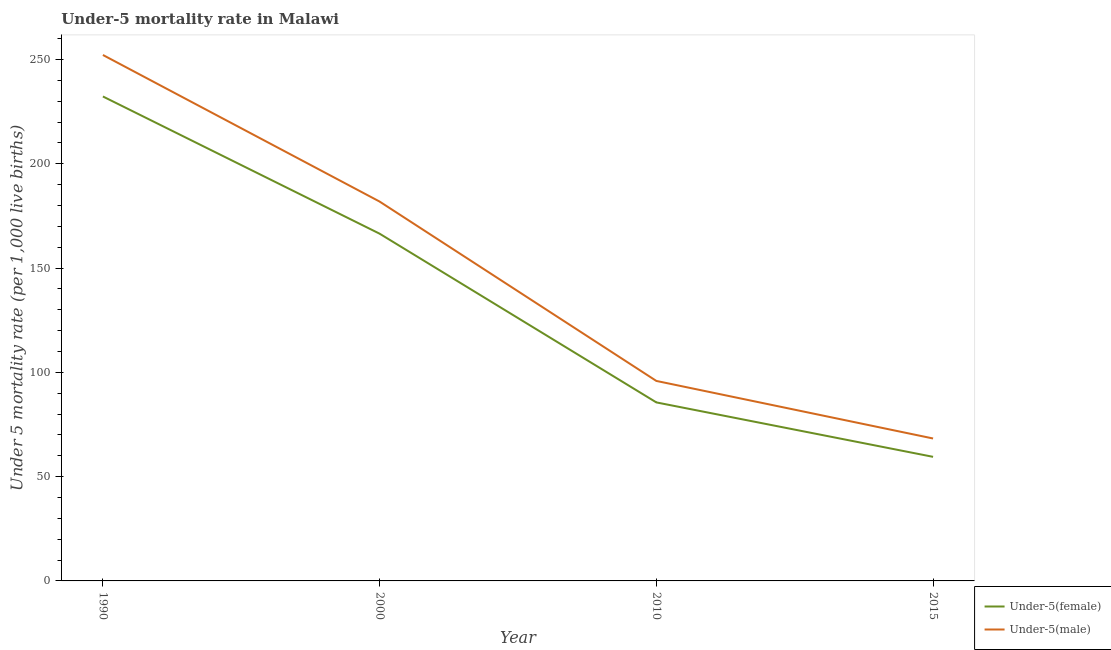Is the number of lines equal to the number of legend labels?
Provide a succinct answer. Yes. What is the under-5 female mortality rate in 2000?
Give a very brief answer. 166.5. Across all years, what is the maximum under-5 male mortality rate?
Make the answer very short. 252.2. Across all years, what is the minimum under-5 male mortality rate?
Your answer should be compact. 68.3. In which year was the under-5 female mortality rate minimum?
Ensure brevity in your answer.  2015. What is the total under-5 female mortality rate in the graph?
Give a very brief answer. 543.9. What is the difference between the under-5 female mortality rate in 1990 and that in 2000?
Offer a terse response. 65.8. What is the difference between the under-5 female mortality rate in 2000 and the under-5 male mortality rate in 2010?
Your answer should be compact. 70.6. What is the average under-5 male mortality rate per year?
Your answer should be very brief. 149.57. In the year 2015, what is the difference between the under-5 female mortality rate and under-5 male mortality rate?
Offer a very short reply. -8.8. What is the ratio of the under-5 female mortality rate in 1990 to that in 2000?
Offer a terse response. 1.4. Is the under-5 female mortality rate in 1990 less than that in 2010?
Make the answer very short. No. What is the difference between the highest and the second highest under-5 male mortality rate?
Give a very brief answer. 70.3. What is the difference between the highest and the lowest under-5 male mortality rate?
Provide a succinct answer. 183.9. Is the sum of the under-5 male mortality rate in 1990 and 2000 greater than the maximum under-5 female mortality rate across all years?
Make the answer very short. Yes. Does the under-5 female mortality rate monotonically increase over the years?
Offer a terse response. No. Is the under-5 male mortality rate strictly greater than the under-5 female mortality rate over the years?
Offer a very short reply. Yes. How many lines are there?
Your answer should be compact. 2. Are the values on the major ticks of Y-axis written in scientific E-notation?
Ensure brevity in your answer.  No. Does the graph contain any zero values?
Your response must be concise. No. How many legend labels are there?
Make the answer very short. 2. How are the legend labels stacked?
Provide a short and direct response. Vertical. What is the title of the graph?
Your answer should be compact. Under-5 mortality rate in Malawi. Does "Register a property" appear as one of the legend labels in the graph?
Your answer should be compact. No. What is the label or title of the X-axis?
Offer a terse response. Year. What is the label or title of the Y-axis?
Your answer should be very brief. Under 5 mortality rate (per 1,0 live births). What is the Under 5 mortality rate (per 1,000 live births) of Under-5(female) in 1990?
Provide a short and direct response. 232.3. What is the Under 5 mortality rate (per 1,000 live births) of Under-5(male) in 1990?
Your answer should be very brief. 252.2. What is the Under 5 mortality rate (per 1,000 live births) of Under-5(female) in 2000?
Your answer should be very brief. 166.5. What is the Under 5 mortality rate (per 1,000 live births) of Under-5(male) in 2000?
Ensure brevity in your answer.  181.9. What is the Under 5 mortality rate (per 1,000 live births) of Under-5(female) in 2010?
Your answer should be very brief. 85.6. What is the Under 5 mortality rate (per 1,000 live births) in Under-5(male) in 2010?
Your answer should be compact. 95.9. What is the Under 5 mortality rate (per 1,000 live births) of Under-5(female) in 2015?
Your response must be concise. 59.5. What is the Under 5 mortality rate (per 1,000 live births) of Under-5(male) in 2015?
Offer a terse response. 68.3. Across all years, what is the maximum Under 5 mortality rate (per 1,000 live births) in Under-5(female)?
Offer a terse response. 232.3. Across all years, what is the maximum Under 5 mortality rate (per 1,000 live births) in Under-5(male)?
Your response must be concise. 252.2. Across all years, what is the minimum Under 5 mortality rate (per 1,000 live births) of Under-5(female)?
Offer a terse response. 59.5. Across all years, what is the minimum Under 5 mortality rate (per 1,000 live births) of Under-5(male)?
Provide a succinct answer. 68.3. What is the total Under 5 mortality rate (per 1,000 live births) of Under-5(female) in the graph?
Provide a succinct answer. 543.9. What is the total Under 5 mortality rate (per 1,000 live births) in Under-5(male) in the graph?
Your answer should be compact. 598.3. What is the difference between the Under 5 mortality rate (per 1,000 live births) of Under-5(female) in 1990 and that in 2000?
Make the answer very short. 65.8. What is the difference between the Under 5 mortality rate (per 1,000 live births) in Under-5(male) in 1990 and that in 2000?
Make the answer very short. 70.3. What is the difference between the Under 5 mortality rate (per 1,000 live births) of Under-5(female) in 1990 and that in 2010?
Offer a terse response. 146.7. What is the difference between the Under 5 mortality rate (per 1,000 live births) of Under-5(male) in 1990 and that in 2010?
Make the answer very short. 156.3. What is the difference between the Under 5 mortality rate (per 1,000 live births) in Under-5(female) in 1990 and that in 2015?
Your answer should be very brief. 172.8. What is the difference between the Under 5 mortality rate (per 1,000 live births) of Under-5(male) in 1990 and that in 2015?
Keep it short and to the point. 183.9. What is the difference between the Under 5 mortality rate (per 1,000 live births) in Under-5(female) in 2000 and that in 2010?
Offer a terse response. 80.9. What is the difference between the Under 5 mortality rate (per 1,000 live births) in Under-5(female) in 2000 and that in 2015?
Provide a succinct answer. 107. What is the difference between the Under 5 mortality rate (per 1,000 live births) of Under-5(male) in 2000 and that in 2015?
Ensure brevity in your answer.  113.6. What is the difference between the Under 5 mortality rate (per 1,000 live births) of Under-5(female) in 2010 and that in 2015?
Offer a terse response. 26.1. What is the difference between the Under 5 mortality rate (per 1,000 live births) in Under-5(male) in 2010 and that in 2015?
Your response must be concise. 27.6. What is the difference between the Under 5 mortality rate (per 1,000 live births) in Under-5(female) in 1990 and the Under 5 mortality rate (per 1,000 live births) in Under-5(male) in 2000?
Provide a short and direct response. 50.4. What is the difference between the Under 5 mortality rate (per 1,000 live births) of Under-5(female) in 1990 and the Under 5 mortality rate (per 1,000 live births) of Under-5(male) in 2010?
Your response must be concise. 136.4. What is the difference between the Under 5 mortality rate (per 1,000 live births) of Under-5(female) in 1990 and the Under 5 mortality rate (per 1,000 live births) of Under-5(male) in 2015?
Keep it short and to the point. 164. What is the difference between the Under 5 mortality rate (per 1,000 live births) of Under-5(female) in 2000 and the Under 5 mortality rate (per 1,000 live births) of Under-5(male) in 2010?
Offer a terse response. 70.6. What is the difference between the Under 5 mortality rate (per 1,000 live births) of Under-5(female) in 2000 and the Under 5 mortality rate (per 1,000 live births) of Under-5(male) in 2015?
Your response must be concise. 98.2. What is the average Under 5 mortality rate (per 1,000 live births) of Under-5(female) per year?
Offer a terse response. 135.97. What is the average Under 5 mortality rate (per 1,000 live births) of Under-5(male) per year?
Provide a succinct answer. 149.57. In the year 1990, what is the difference between the Under 5 mortality rate (per 1,000 live births) in Under-5(female) and Under 5 mortality rate (per 1,000 live births) in Under-5(male)?
Keep it short and to the point. -19.9. In the year 2000, what is the difference between the Under 5 mortality rate (per 1,000 live births) of Under-5(female) and Under 5 mortality rate (per 1,000 live births) of Under-5(male)?
Offer a very short reply. -15.4. In the year 2010, what is the difference between the Under 5 mortality rate (per 1,000 live births) in Under-5(female) and Under 5 mortality rate (per 1,000 live births) in Under-5(male)?
Your answer should be very brief. -10.3. What is the ratio of the Under 5 mortality rate (per 1,000 live births) in Under-5(female) in 1990 to that in 2000?
Make the answer very short. 1.4. What is the ratio of the Under 5 mortality rate (per 1,000 live births) of Under-5(male) in 1990 to that in 2000?
Make the answer very short. 1.39. What is the ratio of the Under 5 mortality rate (per 1,000 live births) of Under-5(female) in 1990 to that in 2010?
Offer a terse response. 2.71. What is the ratio of the Under 5 mortality rate (per 1,000 live births) of Under-5(male) in 1990 to that in 2010?
Provide a succinct answer. 2.63. What is the ratio of the Under 5 mortality rate (per 1,000 live births) of Under-5(female) in 1990 to that in 2015?
Ensure brevity in your answer.  3.9. What is the ratio of the Under 5 mortality rate (per 1,000 live births) of Under-5(male) in 1990 to that in 2015?
Your answer should be very brief. 3.69. What is the ratio of the Under 5 mortality rate (per 1,000 live births) in Under-5(female) in 2000 to that in 2010?
Offer a very short reply. 1.95. What is the ratio of the Under 5 mortality rate (per 1,000 live births) of Under-5(male) in 2000 to that in 2010?
Your response must be concise. 1.9. What is the ratio of the Under 5 mortality rate (per 1,000 live births) in Under-5(female) in 2000 to that in 2015?
Your answer should be very brief. 2.8. What is the ratio of the Under 5 mortality rate (per 1,000 live births) in Under-5(male) in 2000 to that in 2015?
Your answer should be very brief. 2.66. What is the ratio of the Under 5 mortality rate (per 1,000 live births) of Under-5(female) in 2010 to that in 2015?
Keep it short and to the point. 1.44. What is the ratio of the Under 5 mortality rate (per 1,000 live births) of Under-5(male) in 2010 to that in 2015?
Ensure brevity in your answer.  1.4. What is the difference between the highest and the second highest Under 5 mortality rate (per 1,000 live births) in Under-5(female)?
Ensure brevity in your answer.  65.8. What is the difference between the highest and the second highest Under 5 mortality rate (per 1,000 live births) of Under-5(male)?
Ensure brevity in your answer.  70.3. What is the difference between the highest and the lowest Under 5 mortality rate (per 1,000 live births) in Under-5(female)?
Offer a terse response. 172.8. What is the difference between the highest and the lowest Under 5 mortality rate (per 1,000 live births) of Under-5(male)?
Your answer should be compact. 183.9. 